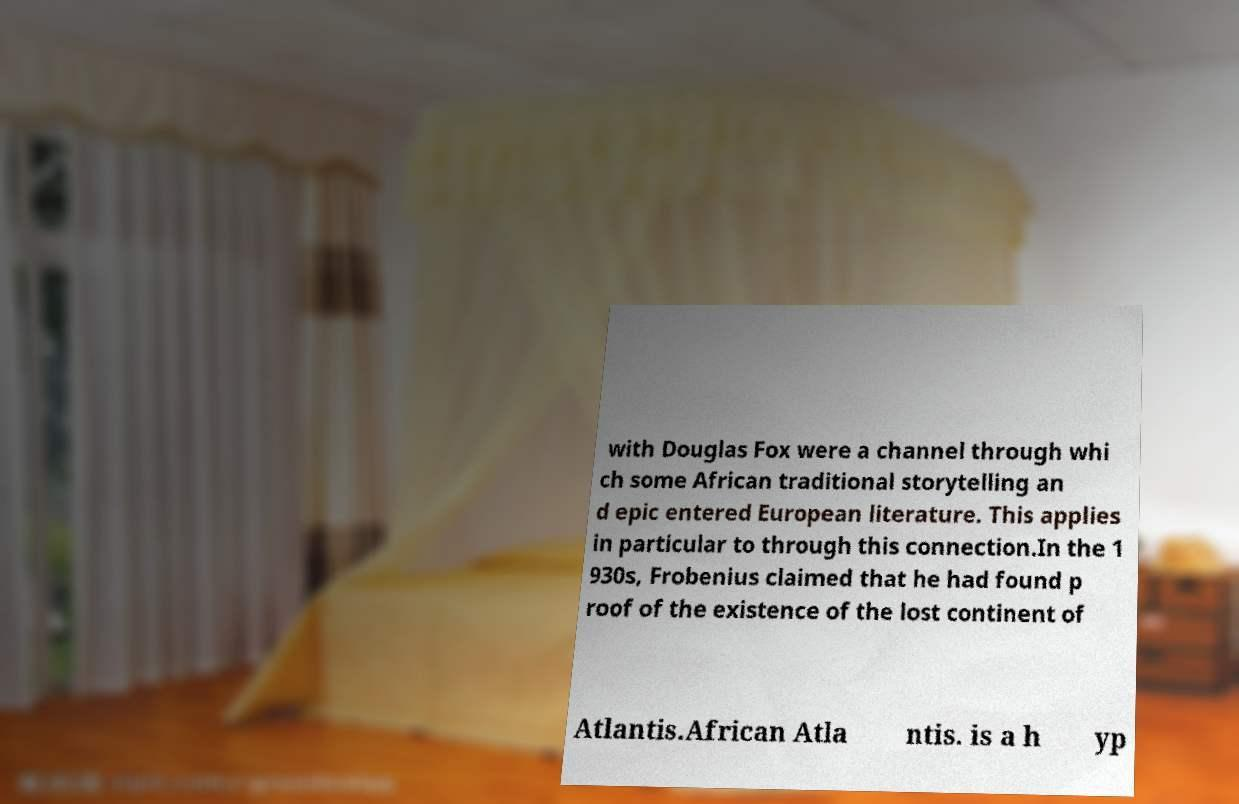Please identify and transcribe the text found in this image. with Douglas Fox were a channel through whi ch some African traditional storytelling an d epic entered European literature. This applies in particular to through this connection.In the 1 930s, Frobenius claimed that he had found p roof of the existence of the lost continent of Atlantis.African Atla ntis. is a h yp 